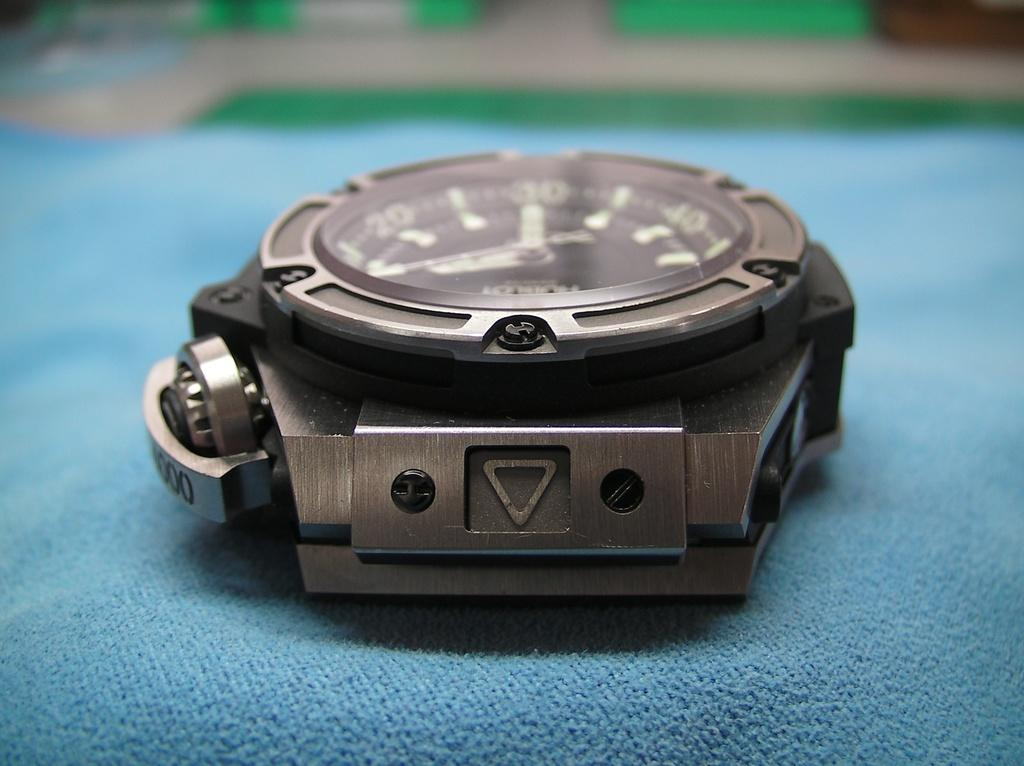<image>
Render a clear and concise summary of the photo. A strapless watch face with three zeros on the edge of it. 